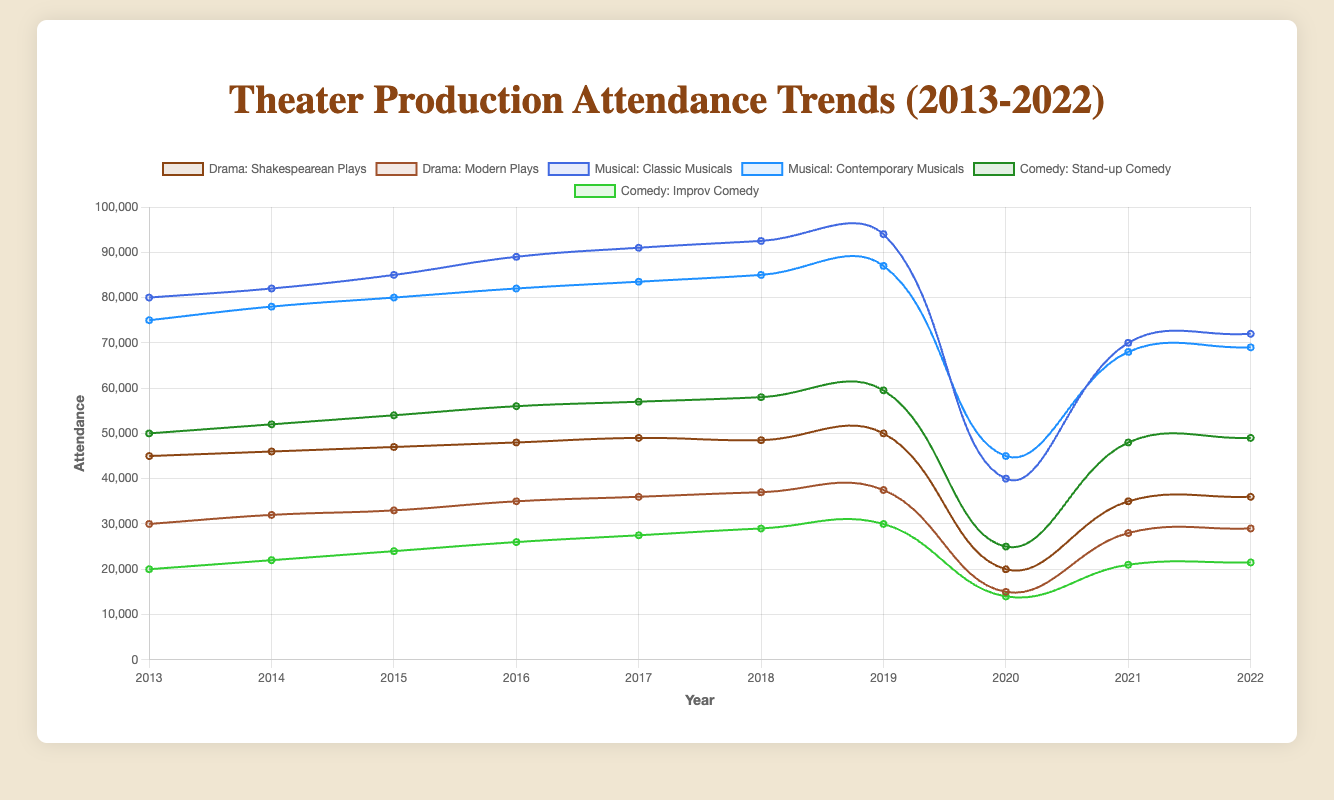How did the attendance for Shakespearean Plays change from 2019 to 2021? In 2019, the attendance for Shakespearean Plays was 50,000. It dropped to 20,000 in 2020, then increased to 35,000 in 2021. The difference from 2019 to 2021 is 50,000 - 35,000 = 15,000
Answer: Decreased by 15,000 Which subgenre had the highest attendance in 2017? By examining all the lines for the year 2017, Classic Musicals had the highest attendance with 91,000 attendees.
Answer: Classic Musicals How did the attendance trends for Modern Plays compare to Improv Comedy from 2014 to 2018? For Modern Plays, attendance increased steadily from 32,000 in 2014 to 37,000 in 2018. For Improv Comedy, attendance also increased from 22,000 in 2014 to 29,000 in 2018. Both subgenres show a positive trend, but Modern Plays had a higher absolute increase.
Answer: Both increased, Modern Plays increased more What was the total attendance for all subgenres in 2020? Sum the attendance for each subgenre in 2020: Shakespearean Plays (20,000) + Modern Plays (15,000) + Classic Musicals (40,000) + Contemporary Musicals (45,000) + Stand-up Comedy (25,000) + Improv Comedy (14,000) = 159,000
Answer: 159,000 Which genre experienced the largest drop in attendance from 2019 to 2020? The genre drops are: Drama (Shakespearean Plays: 30,000, Modern Plays: 22,500), Musical (Classic Musicals: 54,000, Contemporary Musicals: 42,000), Comedy (Stand-up Comedy: 34,500, Improv Comedy: 16,000). The largest drop is in Musicals (Classic Musicals) with 54,000
Answer: Musical (Classic Musicals) What is the difference in attendance between Classic Musicals and Contemporary Musicals in 2022? In 2022, Classic Musicals had an attendance of 72,000 and Contemporary Musicals had 69,000. The difference is 72,000 - 69,000 = 3,000
Answer: 3,000 What were the trends for Stand-up Comedy from 2013 to 2022? From 2013 to 2019, Stand-up Comedy attendance increased from 50,000 to 59,500. In 2020, it dropped sharply to 25,000, then recovered to 49,000 by 2022.
Answer: Increased until 2019, dropped in 2020, partially recovered by 2022 Which subgenre showed a consistent increase in attendance until 2019 without any drops? By examining all lines until 2019, Contemporary Musicals increased from 75,000 in 2013 to 87,000 in 2019 without any drops.
Answer: Contemporary Musicals Across all subgenres, which one had the lowest attendance in 2021? By comparing the lines for the year 2021, Improv Comedy had the lowest attendance with 21,000 attendees.
Answer: Improv Comedy How did the attendance for Classic Musicals and Stand-up Comedy compare in 2021? In 2021, Classic Musicals had an attendance of 70,000, while Stand-up Comedy had 48,000. Classic Musicals had higher attendance than Stand-up Comedy.
Answer: Classic Musicals had higher attendance 